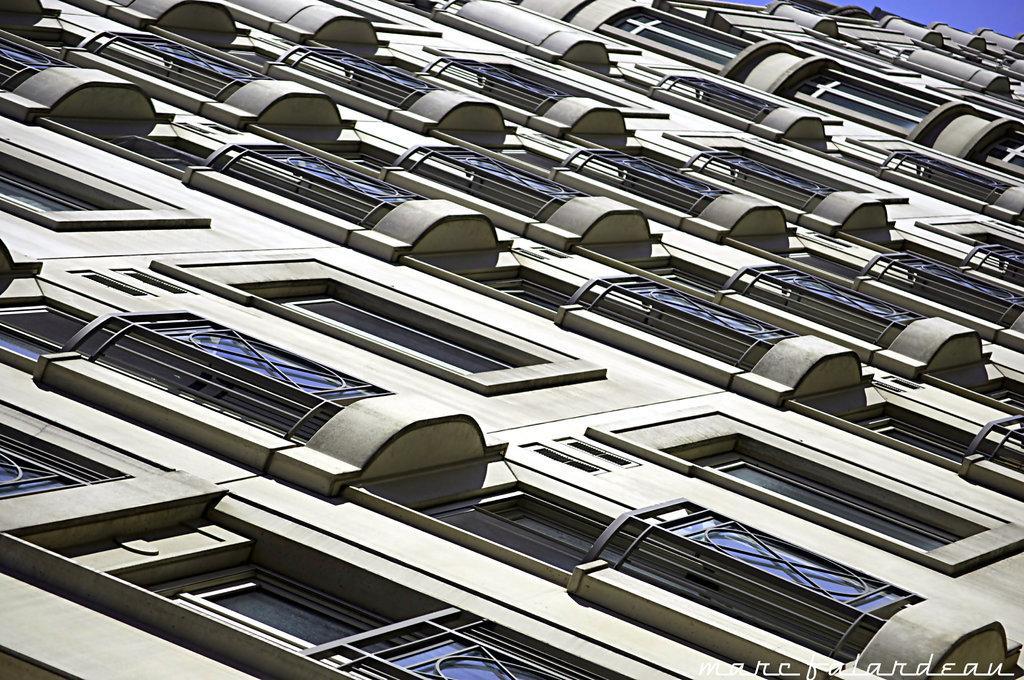How would you summarize this image in a sentence or two? In the image we can see the building and we can see the windows of the building and the sky. 